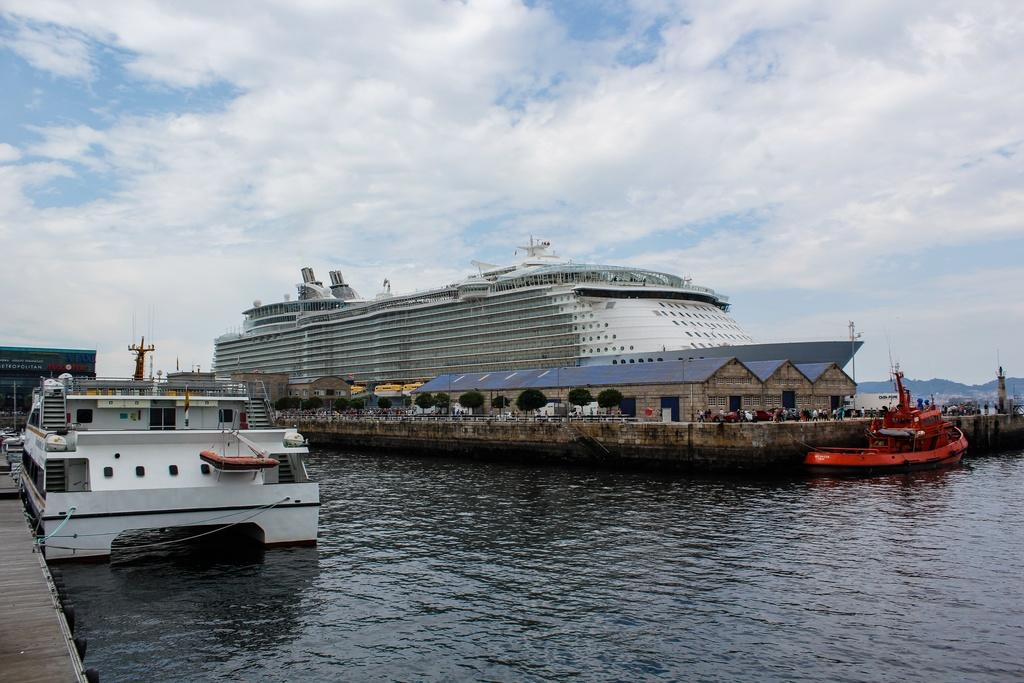What is located near the dock in the image? There is a ship near the dock in the image. What types of boats can be seen floating on the water? There are white and red color boats floating on the water. What can be seen in the background of the image? There are hills and the sky visible in the background of the image. What is the condition of the sky in the image? The sky has clouds in it. What type of rod is used in the design of the ship in the image? There is no specific mention of a rod being used in the design of the ship in the image. 